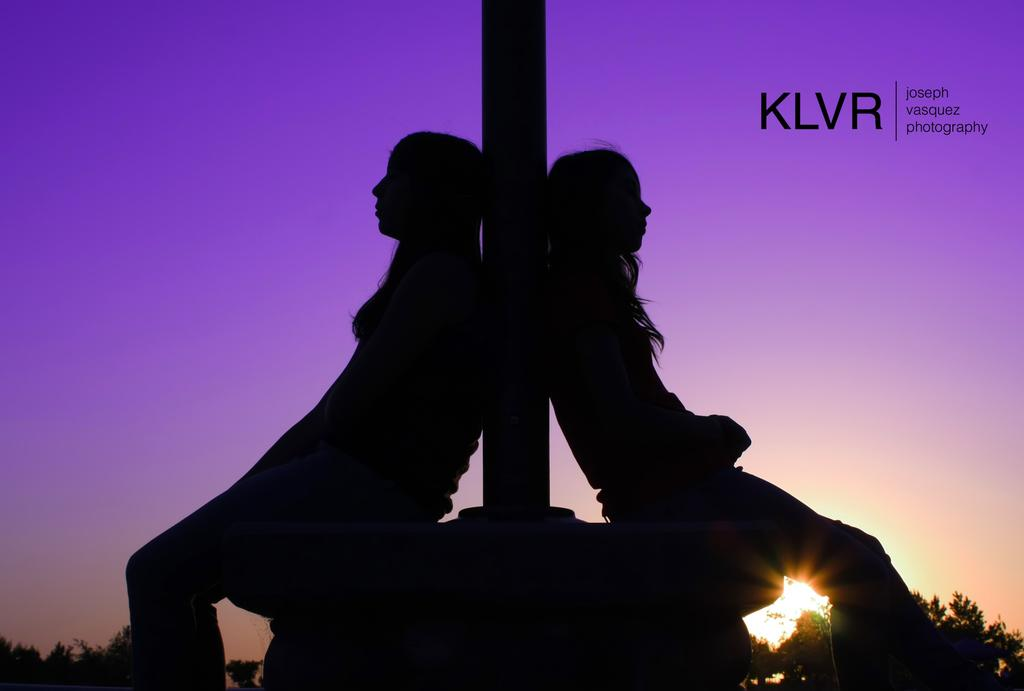What is the main object in the image? There is a pole in the image. Who or what is near the pole? Two ladies are sitting near the pole. What can be seen in the background of the image? There are trees and the sky visible in the background of the image. Is there any text or marking on the image? Yes, there is a watermark in the top right corner of the image. What type of wren can be seen perched on the pole in the image? There is no wren present in the image; it only features a pole and two ladies sitting nearby. How many bananas are being held by the ladies in the image? There are no bananas visible in the image; the ladies are not holding any fruits. 